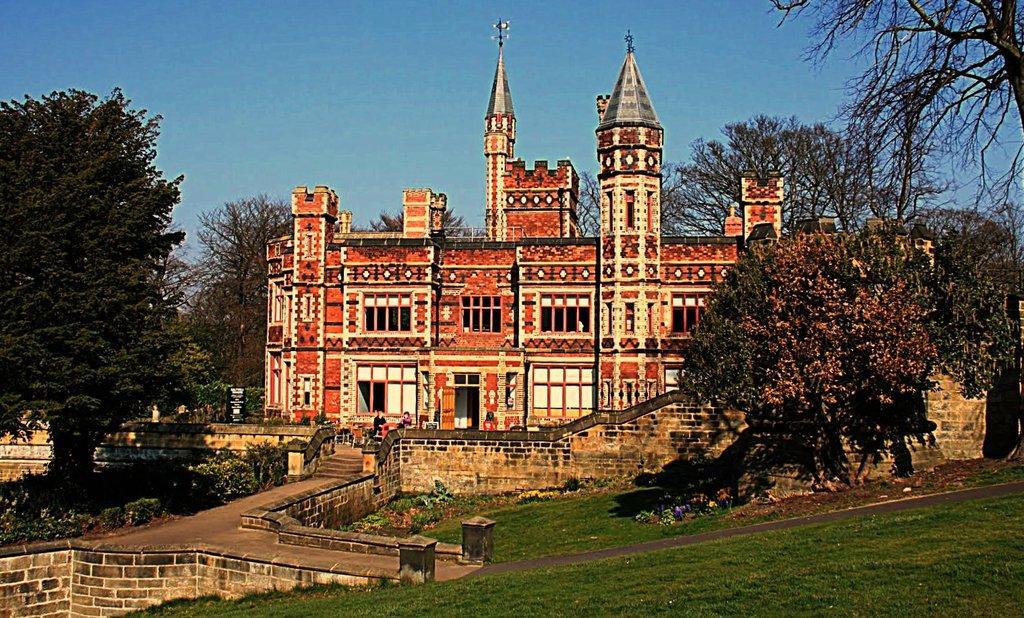How would you summarize this image in a sentence or two? In this image there is a building, in front of the building there are two people, around the building there are trees and there is a display board. 